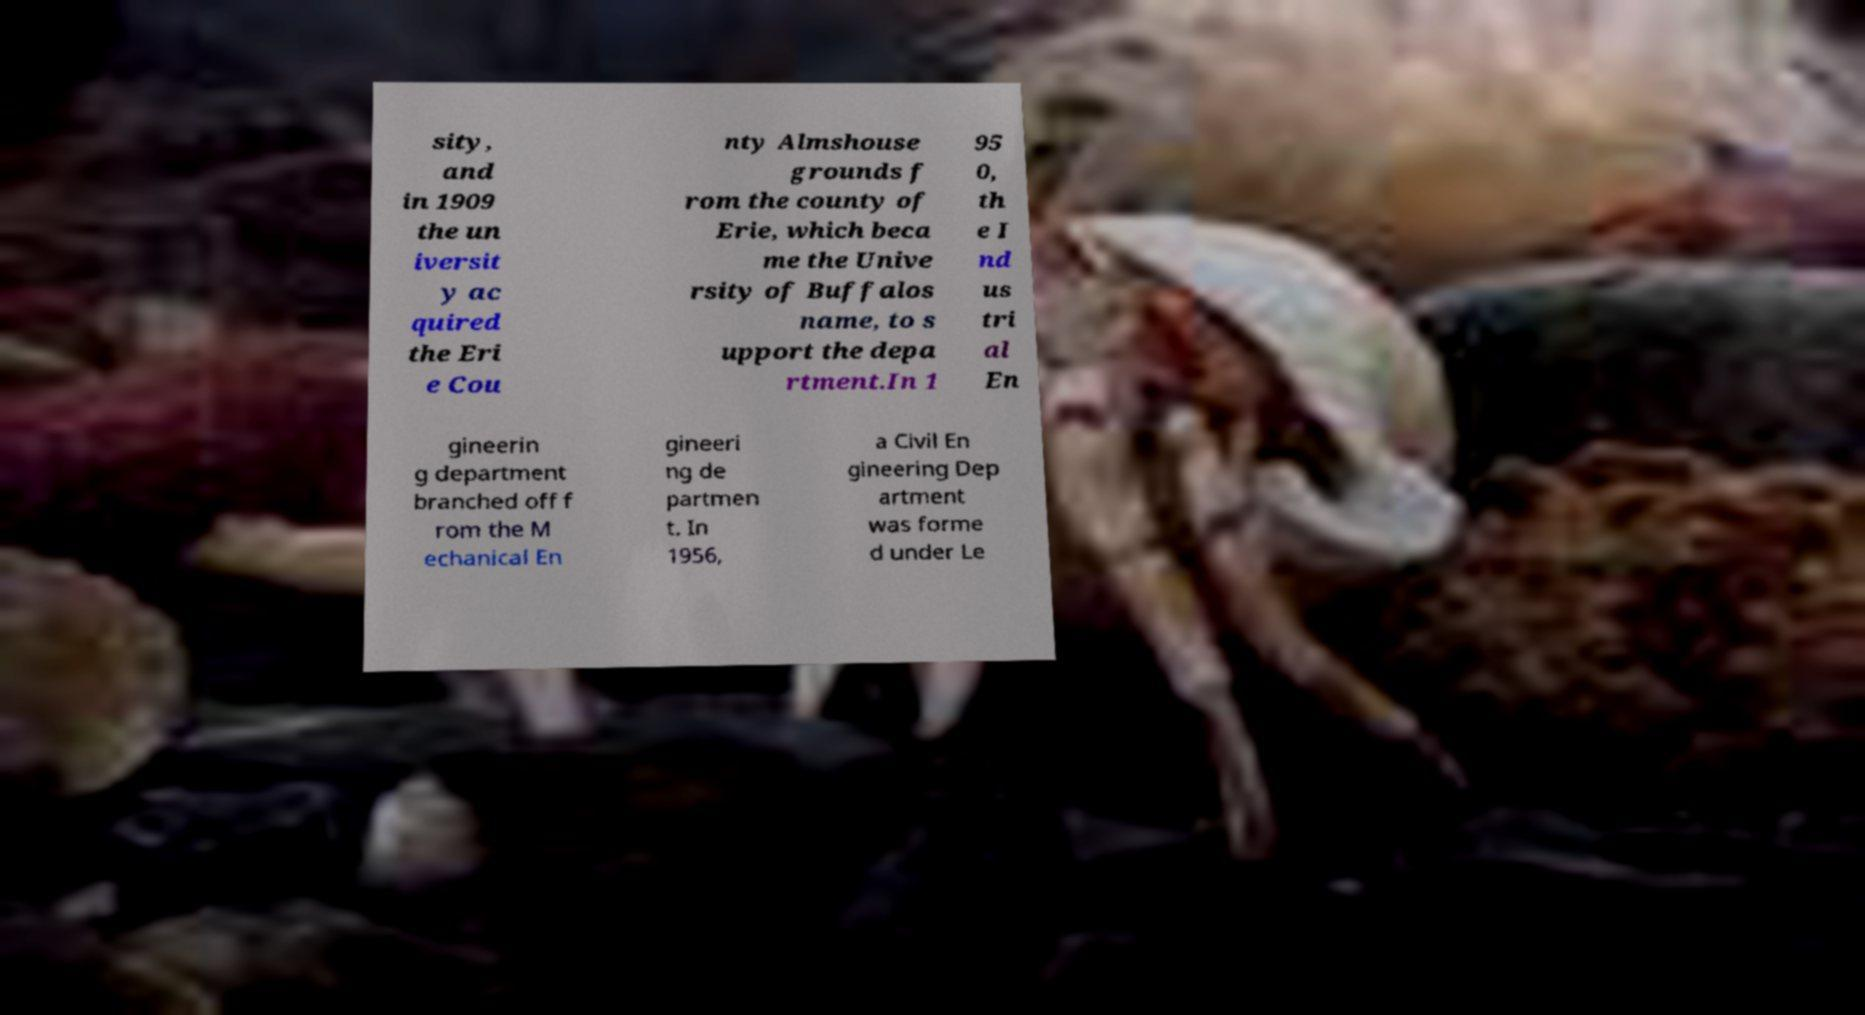Could you extract and type out the text from this image? sity, and in 1909 the un iversit y ac quired the Eri e Cou nty Almshouse grounds f rom the county of Erie, which beca me the Unive rsity of Buffalos name, to s upport the depa rtment.In 1 95 0, th e I nd us tri al En gineerin g department branched off f rom the M echanical En gineeri ng de partmen t. In 1956, a Civil En gineering Dep artment was forme d under Le 